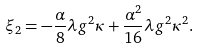<formula> <loc_0><loc_0><loc_500><loc_500>\xi _ { 2 } = - \frac { \alpha } { 8 } \lambda g ^ { 2 } \kappa + \frac { \alpha ^ { 2 } } { 1 6 } \lambda g ^ { 2 } \kappa ^ { 2 } .</formula> 